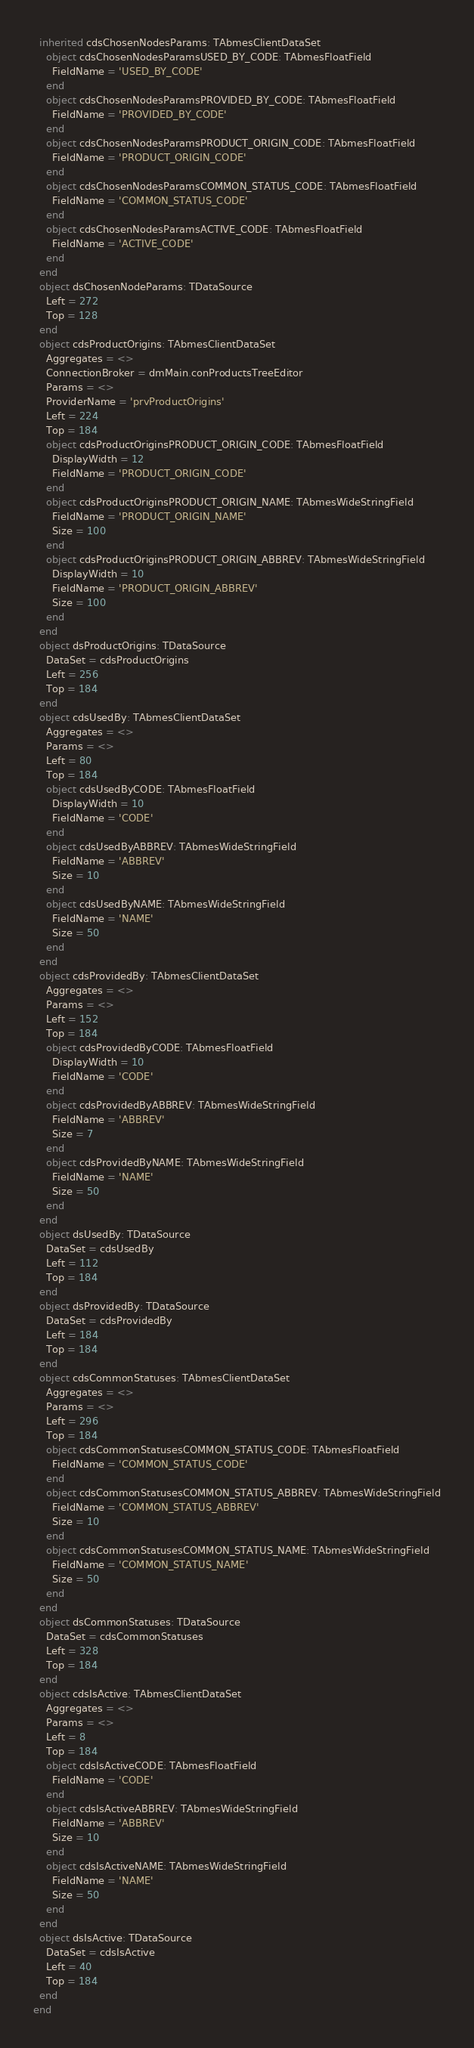Convert code to text. <code><loc_0><loc_0><loc_500><loc_500><_Pascal_>  inherited cdsChosenNodesParams: TAbmesClientDataSet
    object cdsChosenNodesParamsUSED_BY_CODE: TAbmesFloatField
      FieldName = 'USED_BY_CODE'
    end
    object cdsChosenNodesParamsPROVIDED_BY_CODE: TAbmesFloatField
      FieldName = 'PROVIDED_BY_CODE'
    end
    object cdsChosenNodesParamsPRODUCT_ORIGIN_CODE: TAbmesFloatField
      FieldName = 'PRODUCT_ORIGIN_CODE'
    end
    object cdsChosenNodesParamsCOMMON_STATUS_CODE: TAbmesFloatField
      FieldName = 'COMMON_STATUS_CODE'
    end
    object cdsChosenNodesParamsACTIVE_CODE: TAbmesFloatField
      FieldName = 'ACTIVE_CODE'
    end
  end
  object dsChosenNodeParams: TDataSource
    Left = 272
    Top = 128
  end
  object cdsProductOrigins: TAbmesClientDataSet
    Aggregates = <>
    ConnectionBroker = dmMain.conProductsTreeEditor
    Params = <>
    ProviderName = 'prvProductOrigins'
    Left = 224
    Top = 184
    object cdsProductOriginsPRODUCT_ORIGIN_CODE: TAbmesFloatField
      DisplayWidth = 12
      FieldName = 'PRODUCT_ORIGIN_CODE'
    end
    object cdsProductOriginsPRODUCT_ORIGIN_NAME: TAbmesWideStringField
      FieldName = 'PRODUCT_ORIGIN_NAME'
      Size = 100
    end
    object cdsProductOriginsPRODUCT_ORIGIN_ABBREV: TAbmesWideStringField
      DisplayWidth = 10
      FieldName = 'PRODUCT_ORIGIN_ABBREV'
      Size = 100
    end
  end
  object dsProductOrigins: TDataSource
    DataSet = cdsProductOrigins
    Left = 256
    Top = 184
  end
  object cdsUsedBy: TAbmesClientDataSet
    Aggregates = <>
    Params = <>
    Left = 80
    Top = 184
    object cdsUsedByCODE: TAbmesFloatField
      DisplayWidth = 10
      FieldName = 'CODE'
    end
    object cdsUsedByABBREV: TAbmesWideStringField
      FieldName = 'ABBREV'
      Size = 10
    end
    object cdsUsedByNAME: TAbmesWideStringField
      FieldName = 'NAME'
      Size = 50
    end
  end
  object cdsProvidedBy: TAbmesClientDataSet
    Aggregates = <>
    Params = <>
    Left = 152
    Top = 184
    object cdsProvidedByCODE: TAbmesFloatField
      DisplayWidth = 10
      FieldName = 'CODE'
    end
    object cdsProvidedByABBREV: TAbmesWideStringField
      FieldName = 'ABBREV'
      Size = 7
    end
    object cdsProvidedByNAME: TAbmesWideStringField
      FieldName = 'NAME'
      Size = 50
    end
  end
  object dsUsedBy: TDataSource
    DataSet = cdsUsedBy
    Left = 112
    Top = 184
  end
  object dsProvidedBy: TDataSource
    DataSet = cdsProvidedBy
    Left = 184
    Top = 184
  end
  object cdsCommonStatuses: TAbmesClientDataSet
    Aggregates = <>
    Params = <>
    Left = 296
    Top = 184
    object cdsCommonStatusesCOMMON_STATUS_CODE: TAbmesFloatField
      FieldName = 'COMMON_STATUS_CODE'
    end
    object cdsCommonStatusesCOMMON_STATUS_ABBREV: TAbmesWideStringField
      FieldName = 'COMMON_STATUS_ABBREV'
      Size = 10
    end
    object cdsCommonStatusesCOMMON_STATUS_NAME: TAbmesWideStringField
      FieldName = 'COMMON_STATUS_NAME'
      Size = 50
    end
  end
  object dsCommonStatuses: TDataSource
    DataSet = cdsCommonStatuses
    Left = 328
    Top = 184
  end
  object cdsIsActive: TAbmesClientDataSet
    Aggregates = <>
    Params = <>
    Left = 8
    Top = 184
    object cdsIsActiveCODE: TAbmesFloatField
      FieldName = 'CODE'
    end
    object cdsIsActiveABBREV: TAbmesWideStringField
      FieldName = 'ABBREV'
      Size = 10
    end
    object cdsIsActiveNAME: TAbmesWideStringField
      FieldName = 'NAME'
      Size = 50
    end
  end
  object dsIsActive: TDataSource
    DataSet = cdsIsActive
    Left = 40
    Top = 184
  end
end
</code> 